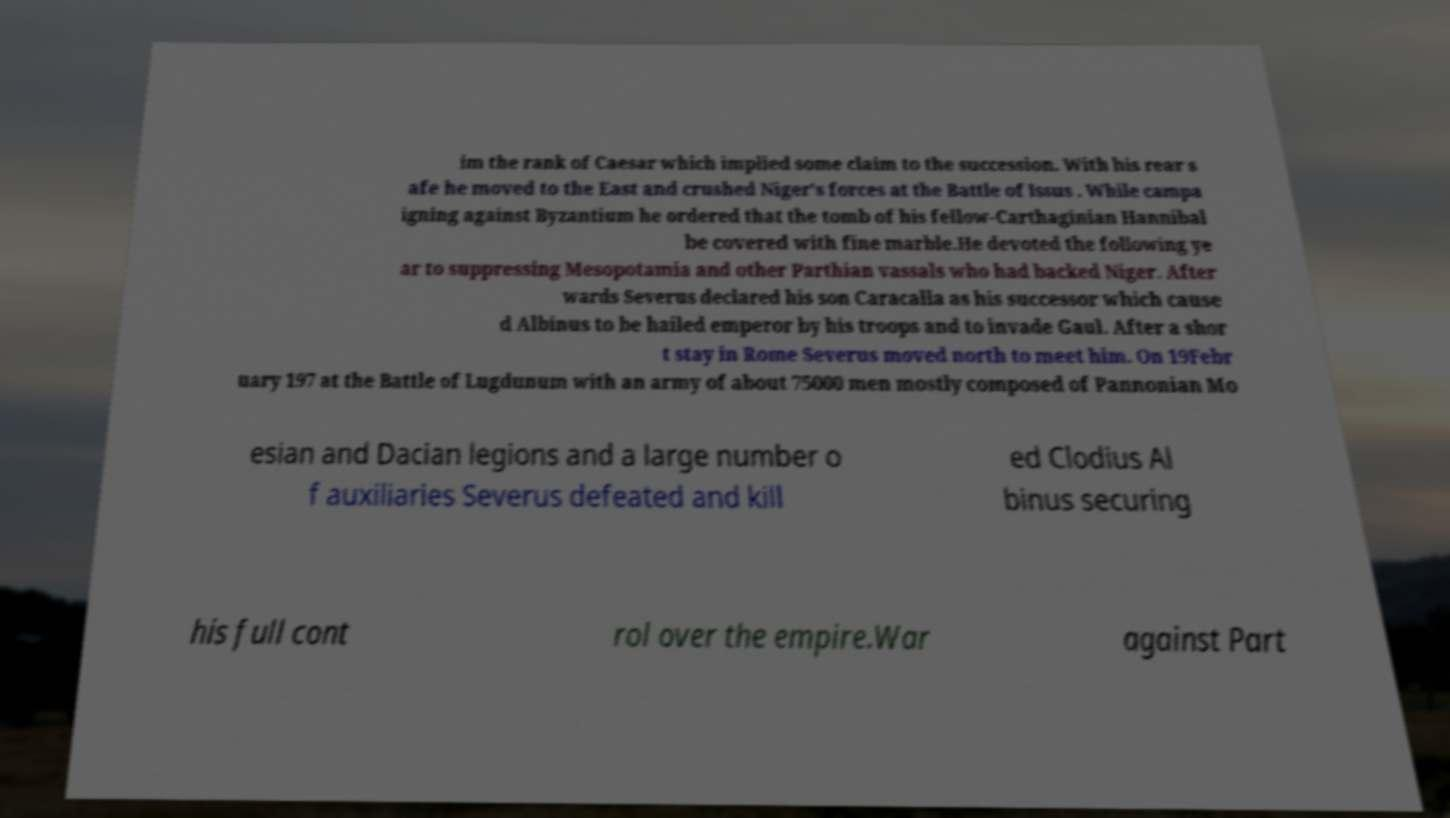For documentation purposes, I need the text within this image transcribed. Could you provide that? im the rank of Caesar which implied some claim to the succession. With his rear s afe he moved to the East and crushed Niger's forces at the Battle of Issus . While campa igning against Byzantium he ordered that the tomb of his fellow-Carthaginian Hannibal be covered with fine marble.He devoted the following ye ar to suppressing Mesopotamia and other Parthian vassals who had backed Niger. After wards Severus declared his son Caracalla as his successor which cause d Albinus to be hailed emperor by his troops and to invade Gaul. After a shor t stay in Rome Severus moved north to meet him. On 19Febr uary 197 at the Battle of Lugdunum with an army of about 75000 men mostly composed of Pannonian Mo esian and Dacian legions and a large number o f auxiliaries Severus defeated and kill ed Clodius Al binus securing his full cont rol over the empire.War against Part 